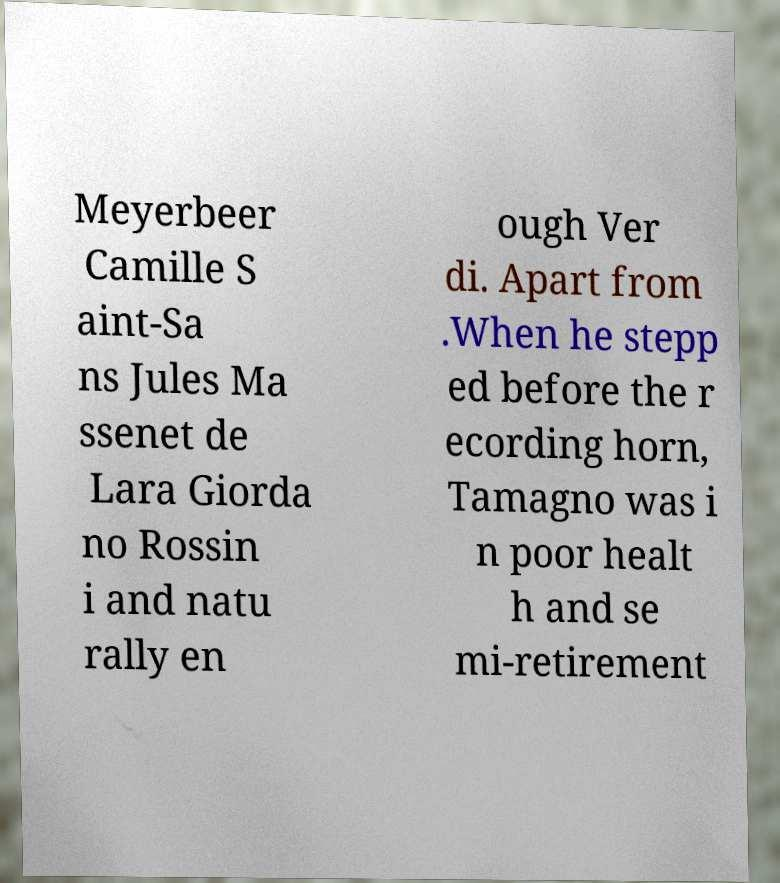For documentation purposes, I need the text within this image transcribed. Could you provide that? Meyerbeer Camille S aint-Sa ns Jules Ma ssenet de Lara Giorda no Rossin i and natu rally en ough Ver di. Apart from .When he stepp ed before the r ecording horn, Tamagno was i n poor healt h and se mi-retirement 